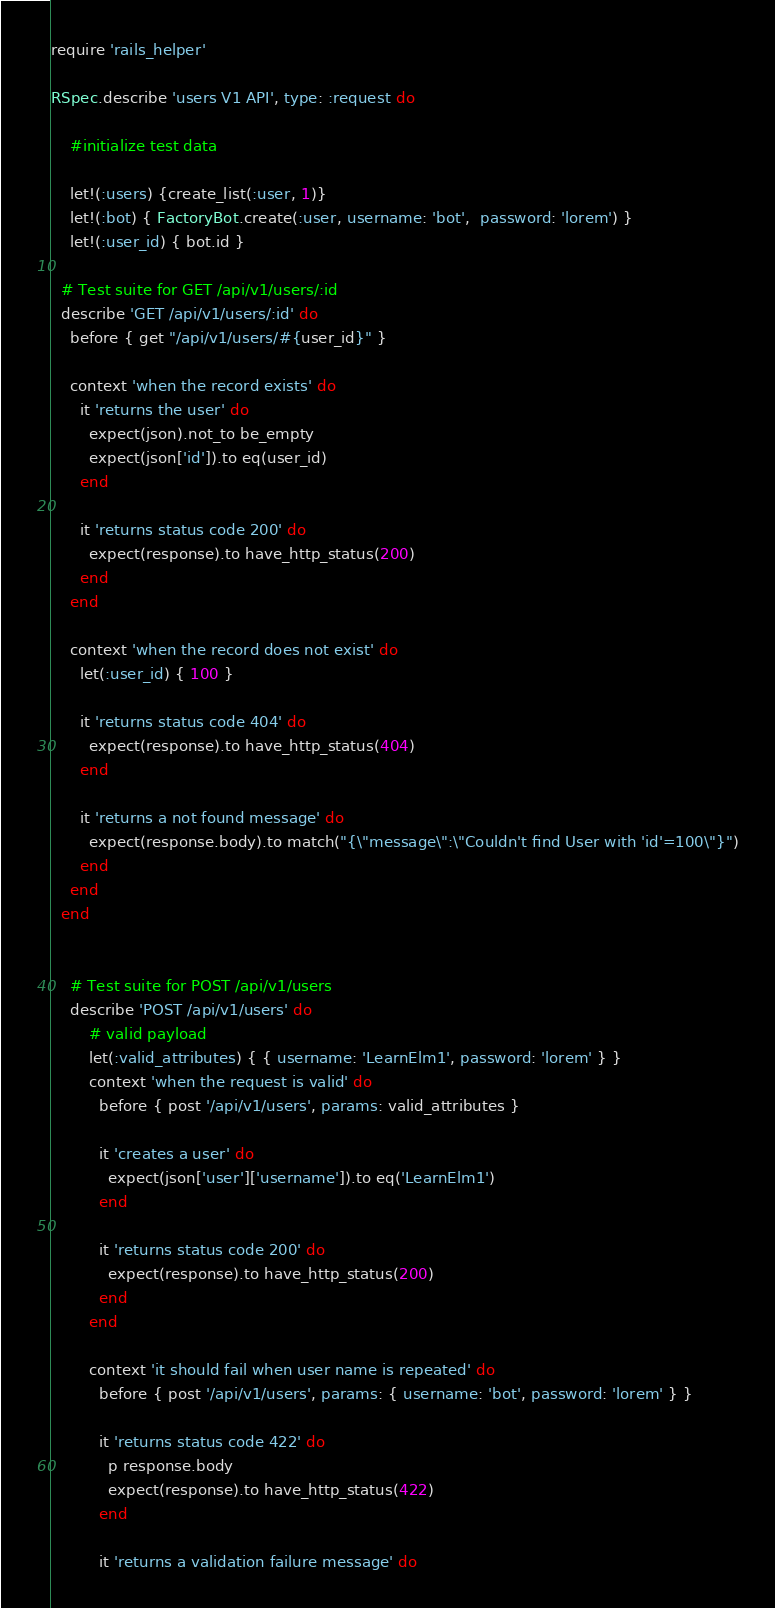Convert code to text. <code><loc_0><loc_0><loc_500><loc_500><_Ruby_>require 'rails_helper'

RSpec.describe 'users V1 API', type: :request do

    #initialize test data

    let!(:users) {create_list(:user, 1)}
    let!(:bot) { FactoryBot.create(:user, username: 'bot',  password: 'lorem') }
    let!(:user_id) { bot.id }

  # Test suite for GET /api/v1/users/:id
  describe 'GET /api/v1/users/:id' do
    before { get "/api/v1/users/#{user_id}" }

    context 'when the record exists' do
      it 'returns the user' do
        expect(json).not_to be_empty
        expect(json['id']).to eq(user_id)
      end

      it 'returns status code 200' do
        expect(response).to have_http_status(200)
      end
    end

    context 'when the record does not exist' do
      let(:user_id) { 100 }

      it 'returns status code 404' do
        expect(response).to have_http_status(404)
      end

      it 'returns a not found message' do
        expect(response.body).to match("{\"message\":\"Couldn't find User with 'id'=100\"}")
      end
    end
  end    


    # Test suite for POST /api/v1/users
    describe 'POST /api/v1/users' do
        # valid payload
        let(:valid_attributes) { { username: 'LearnElm1', password: 'lorem' } }    
        context 'when the request is valid' do
          before { post '/api/v1/users', params: valid_attributes }
    
          it 'creates a user' do
            expect(json['user']['username']).to eq('LearnElm1')
          end
    
          it 'returns status code 200' do
            expect(response).to have_http_status(200)
          end
        end

        context 'it should fail when user name is repeated' do
          before { post '/api/v1/users', params: { username: 'bot', password: 'lorem' } }
    
          it 'returns status code 422' do
            p response.body
            expect(response).to have_http_status(422)
          end
    
          it 'returns a validation failure message' do</code> 